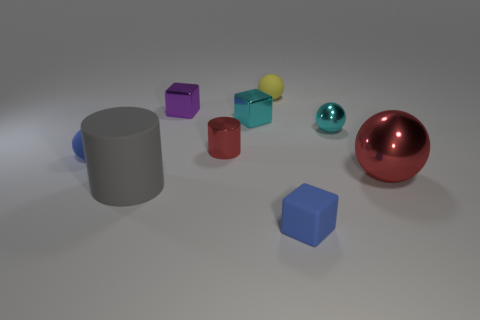What could the different colors of the objects represent if this was an abstract art piece? The diverse colors could represent a spectrum of emotions or ideas. For instance, the purple cube might symbolize royalty or mystery, the red sphere could indicate passion or energy, while the yellow cube could represent happiness or caution, offering a visual narrative to the viewer. And what about the arrangement of the objects? Their scattered placement might suggest a sense of randomness or chaos, implying that emotions and ideas don't always follow a logical pattern, but rather come in assorted and unexpected forms. 